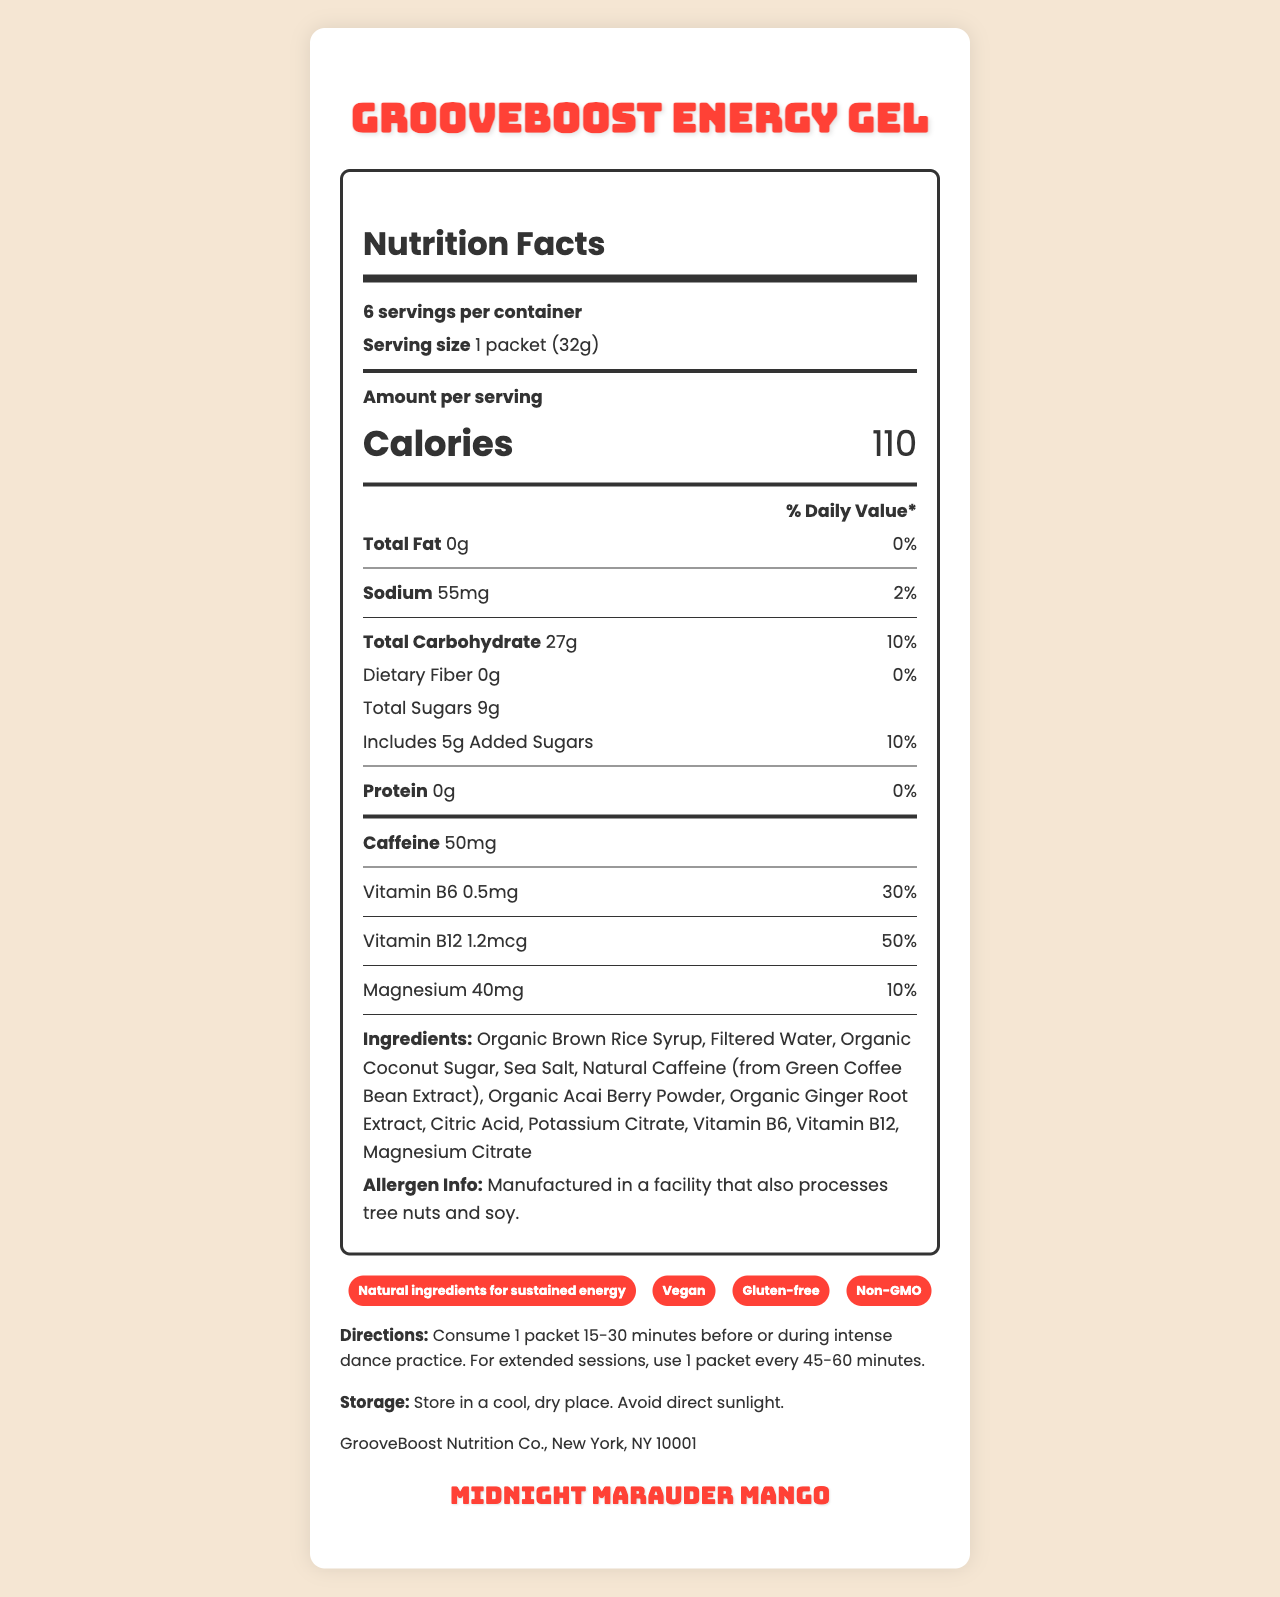Who is the manufacturer of GrooveBoost Energy Gel? The manufacturer information is listed at the bottom of the document.
Answer: GrooveBoost Nutrition Co., New York, NY 10001 How many servings are there in one container of GrooveBoost Energy Gel? The document states that there are 6 servings per container.
Answer: 6 How many calories are in one serving of GrooveBoost Energy Gel? The document indicates that each serving contains 110 calories.
Answer: 110 calories What is the Tribe Called Quest-inspired flavor of GrooveBoost Energy Gel? This flavor is listed as "Midnight Marauder Mango" near the bottom of the document.
Answer: Midnight Marauder Mango Which vitamin has the highest % daily value per serving? The document notes that Vitamin B12 has a 50% daily value per serving.
Answer: Vitamin B12 What is the serving size for GrooveBoost Energy Gel? The document states that the serving size is 1 packet (32g).
Answer: 1 packet (32g) When should you consume GrooveBoost Energy Gel for best results? A. After dance practice B. During intense dance practice C. 15-30 minutes before dance practice D. Both B and C The directions indicate that one should consume the product 15-30 minutes before or during intense dance practice.
Answer: D Which of the following claims is NOT made about GrooveBoost Energy Gel? A. Gluten-free B. Organic C. Vegan D. Non-GMO While the document mentions "Vegan," "Gluten-free," and "Non-GMO", it does not claim the product is "Organic".
Answer: B Does GrooveBoost Energy Gel contain any protein? The document lists 0g protein per serving.
Answer: No Is the GrooveBoost Energy Gel gluten-free? The product claims section lists "Gluten-free" as one of the claims.
Answer: Yes Describe the main idea of the document. This summary captures the different sections and essential details provided in the document.
Answer: The document provides detailed nutritional information, ingredients, directions for use, storage instructions, and product claims for GrooveBoost Energy Gel, which is designed to offer sustained energy for dance practice. How much total carbohydrate is in one serving of GrooveBoost Energy Gel? The nutrition facts show that there are 27g of total carbohydrates per serving.
Answer: 27g What is the total amount of added sugars in one serving of GrooveBoost Energy Gel? The document indicates that each serving includes 5g of added sugars.
Answer: 5g Does GrooveBoost Energy Gel contain any dietary fiber? The document lists 0g dietary fiber per serving.
Answer: No How much caffeine is in one serving of GrooveBoost Energy Gel? The nutrition facts state that there are 50mg of caffeine per serving.
Answer: 50mg What are the ingredients in GrooveBoost Energy Gel? The ingredients are listed in the document under the ingredients section.
Answer: Organic Brown Rice Syrup, Filtered Water, Organic Coconut Sugar, Sea Salt, Natural Caffeine (from Green Coffee Bean Extract), Organic Acai Berry Powder, Organic Ginger Root Extract, Citric Acid, Potassium Citrate, Vitamin B6, Vitamin B12, Magnesium Citrate What facility information is provided regarding allergens? The document includes this information, stating that the product is manufactured in a facility that processes tree nuts and soy.
Answer: Manufactured in a facility that also processes tree nuts and soy. What is the percentage daily value of sodium per serving? The document lists the sodium daily value percentage as 2%.
Answer: 2% Can we determine the cost of GrooveBoost Energy Gel from the document? The document does not provide any information regarding the price or cost of the product.
Answer: Cannot be determined 